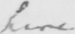Please transcribe the handwritten text in this image. here 